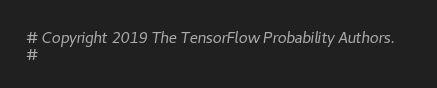Convert code to text. <code><loc_0><loc_0><loc_500><loc_500><_Python_># Copyright 2019 The TensorFlow Probability Authors.
#</code> 